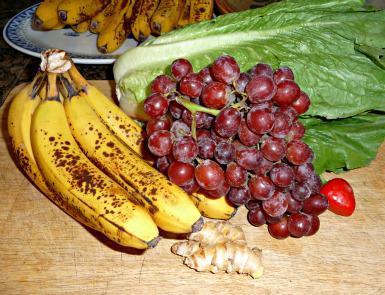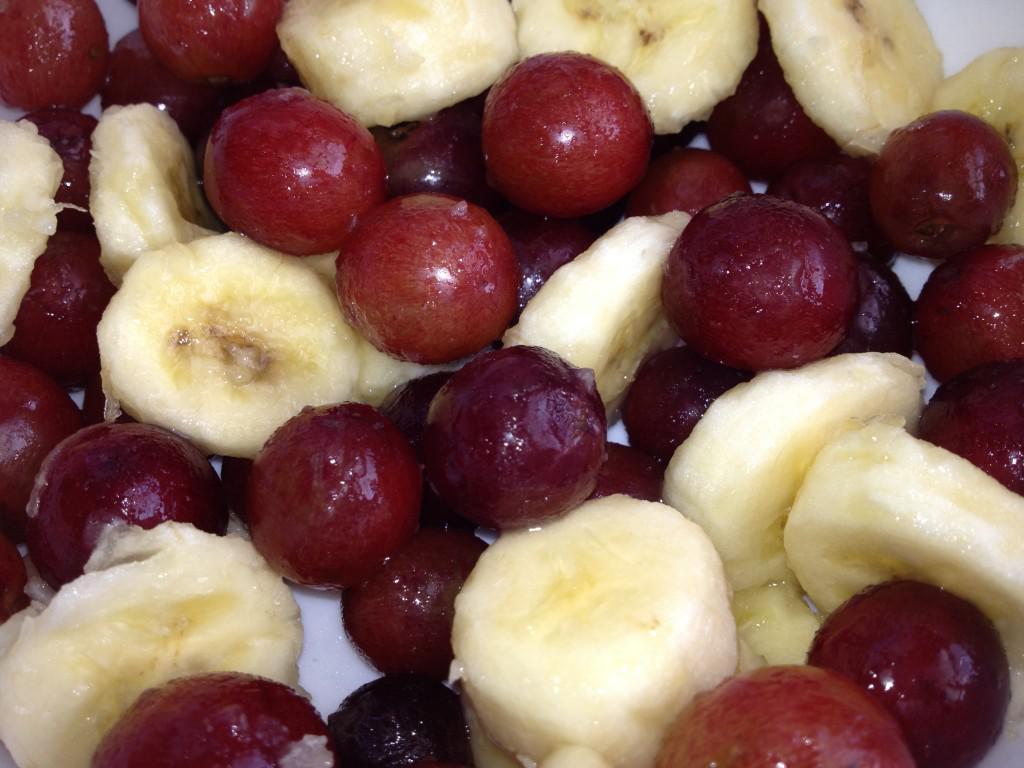The first image is the image on the left, the second image is the image on the right. Examine the images to the left and right. Is the description "An image shows a basket filled with unpeeled bananas, green grapes, and reddish-purple plums." accurate? Answer yes or no. No. 